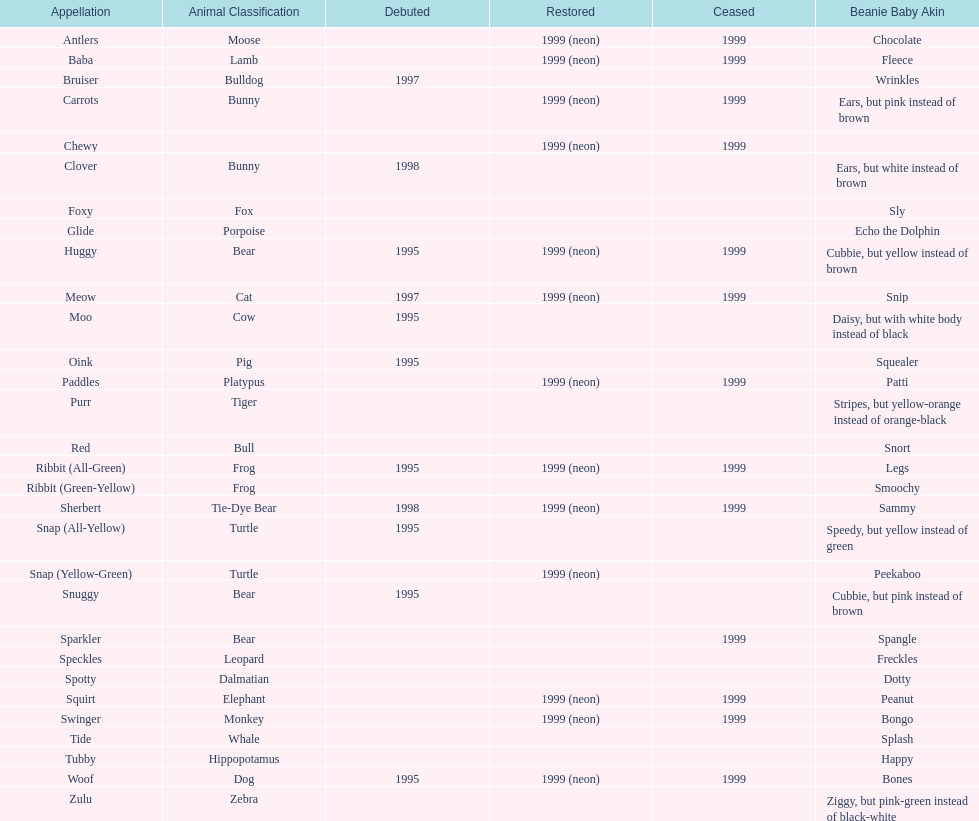Which is the only pillow pal without a listed animal type? Chewy. 